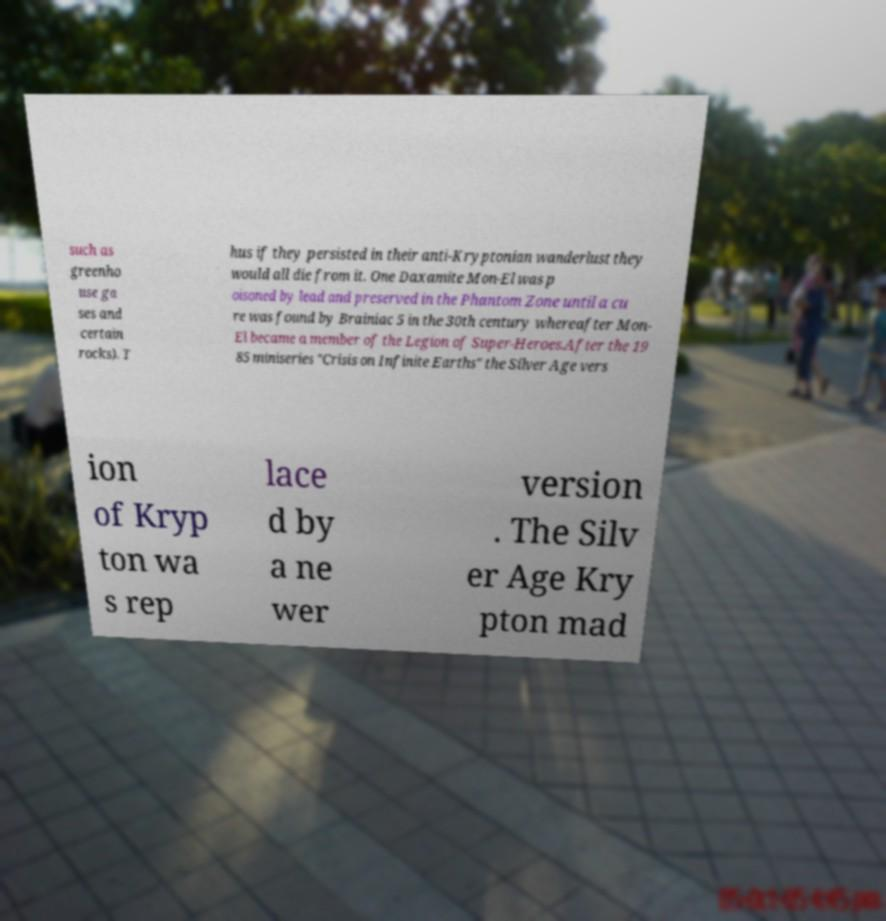What messages or text are displayed in this image? I need them in a readable, typed format. such as greenho use ga ses and certain rocks). T hus if they persisted in their anti-Kryptonian wanderlust they would all die from it. One Daxamite Mon-El was p oisoned by lead and preserved in the Phantom Zone until a cu re was found by Brainiac 5 in the 30th century whereafter Mon- El became a member of the Legion of Super-Heroes.After the 19 85 miniseries "Crisis on Infinite Earths" the Silver Age vers ion of Kryp ton wa s rep lace d by a ne wer version . The Silv er Age Kry pton mad 